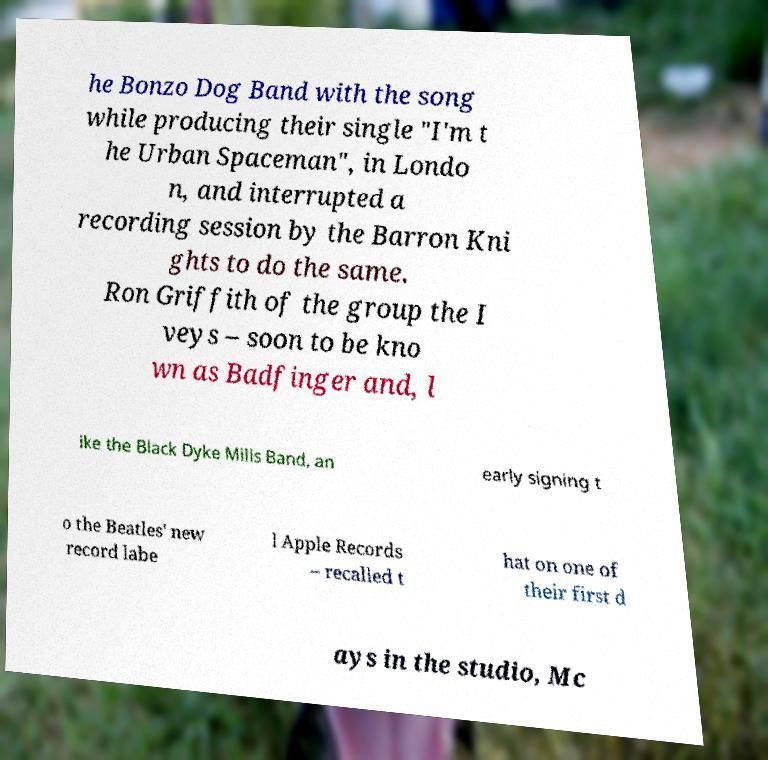For documentation purposes, I need the text within this image transcribed. Could you provide that? he Bonzo Dog Band with the song while producing their single "I'm t he Urban Spaceman", in Londo n, and interrupted a recording session by the Barron Kni ghts to do the same. Ron Griffith of the group the I veys – soon to be kno wn as Badfinger and, l ike the Black Dyke Mills Band, an early signing t o the Beatles' new record labe l Apple Records – recalled t hat on one of their first d ays in the studio, Mc 